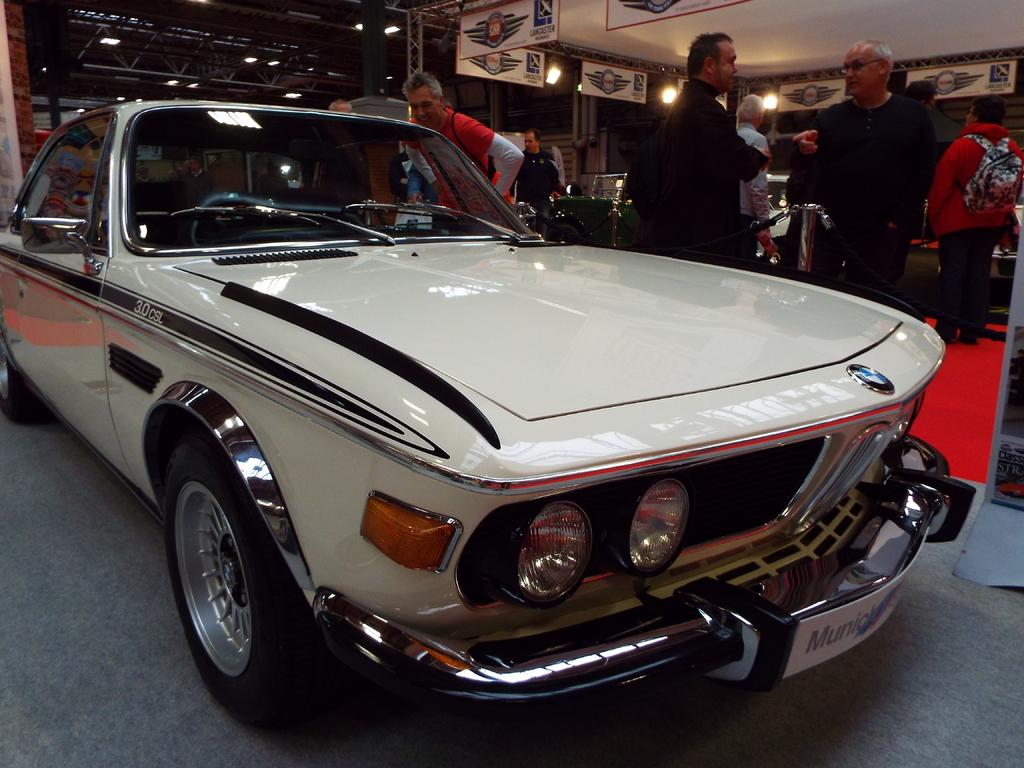What color is the car in the image? The car in the image is white. Where is the car located in the image? The car is on the floor. What else can be seen in the image besides the car? There are people standing in the image. What can be seen in the background of the image? There are white color boards and yellow color lights in the background of the image. What language are the people speaking in the image? The provided facts do not mention any language spoken by the people in the image, so we cannot determine the language from the image. 